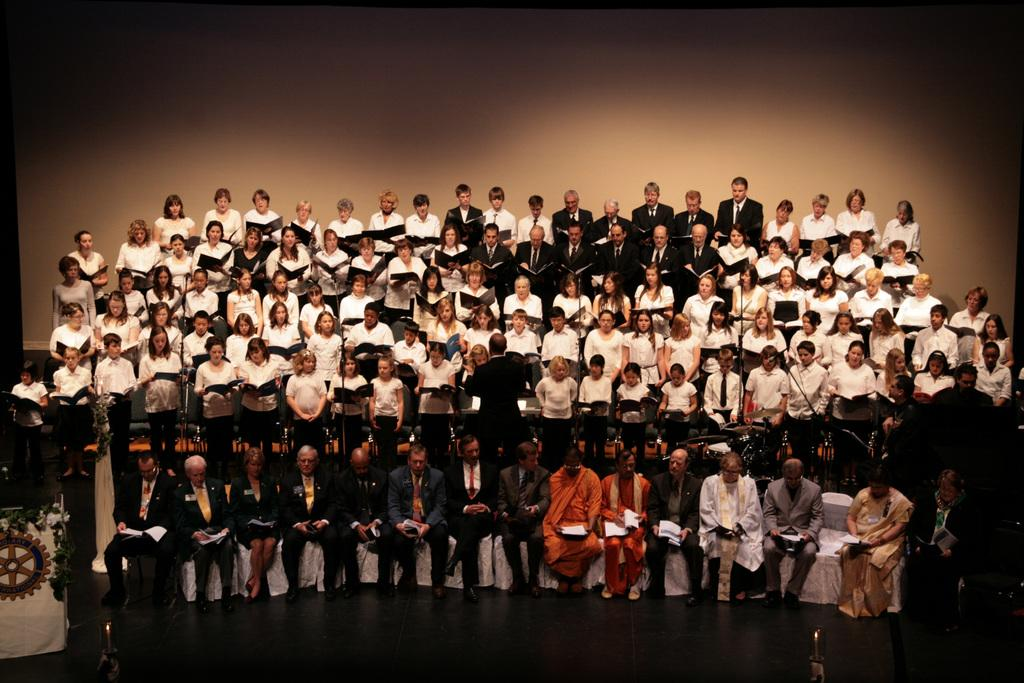What is the main subject of the image? The main subject of the image is a group of people. What are the people in the image doing? Some people are standing, while others are sitting on chairs. What are the people holding in the image? The people are holding books. What can be observed about the people's clothing in the image? The people are wearing different color dress. What type of rake is being used by the person in the image? There is no rake present in the image; the people are holding books. What action is the person in the image performing? The question cannot be answered definitively as the image shows a group of people in various positions and actions, but it does not specify any particular action for a single person. 